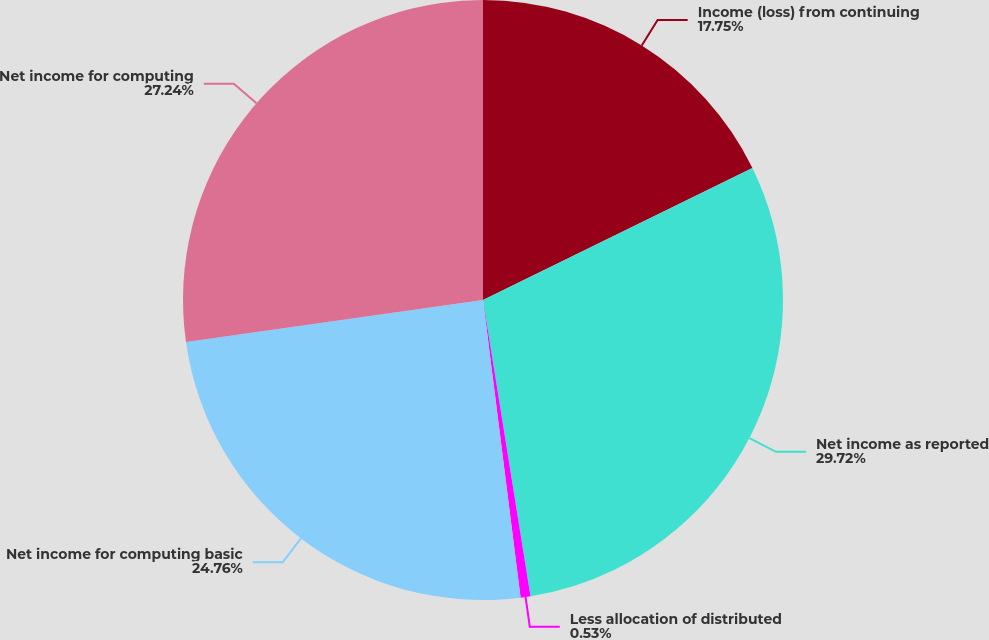Convert chart. <chart><loc_0><loc_0><loc_500><loc_500><pie_chart><fcel>Income (loss) from continuing<fcel>Net income as reported<fcel>Less allocation of distributed<fcel>Net income for computing basic<fcel>Net income for computing<nl><fcel>17.75%<fcel>29.72%<fcel>0.53%<fcel>24.76%<fcel>27.24%<nl></chart> 